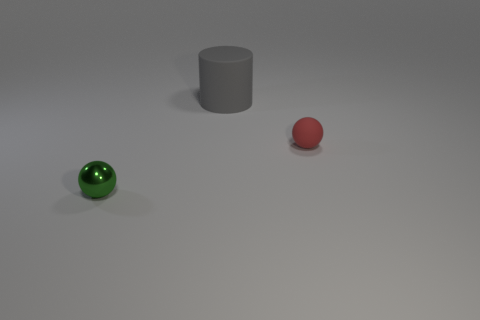Is there anything else that is the same size as the rubber cylinder?
Your answer should be very brief. No. Are there more large gray rubber things than things?
Keep it short and to the point. No. What number of objects are either big rubber spheres or tiny matte spheres?
Ensure brevity in your answer.  1. Do the tiny object on the left side of the small red rubber ball and the small red matte thing have the same shape?
Your response must be concise. Yes. What is the color of the small sphere left of the rubber object that is on the right side of the gray object?
Make the answer very short. Green. Are there fewer shiny spheres than red matte cubes?
Keep it short and to the point. No. Is there a big green cylinder that has the same material as the green ball?
Give a very brief answer. No. Do the large matte object and the small thing that is behind the tiny shiny ball have the same shape?
Keep it short and to the point. No. There is a gray thing; are there any large gray matte cylinders behind it?
Your response must be concise. No. What number of other big things have the same shape as the metallic object?
Your answer should be very brief. 0. 